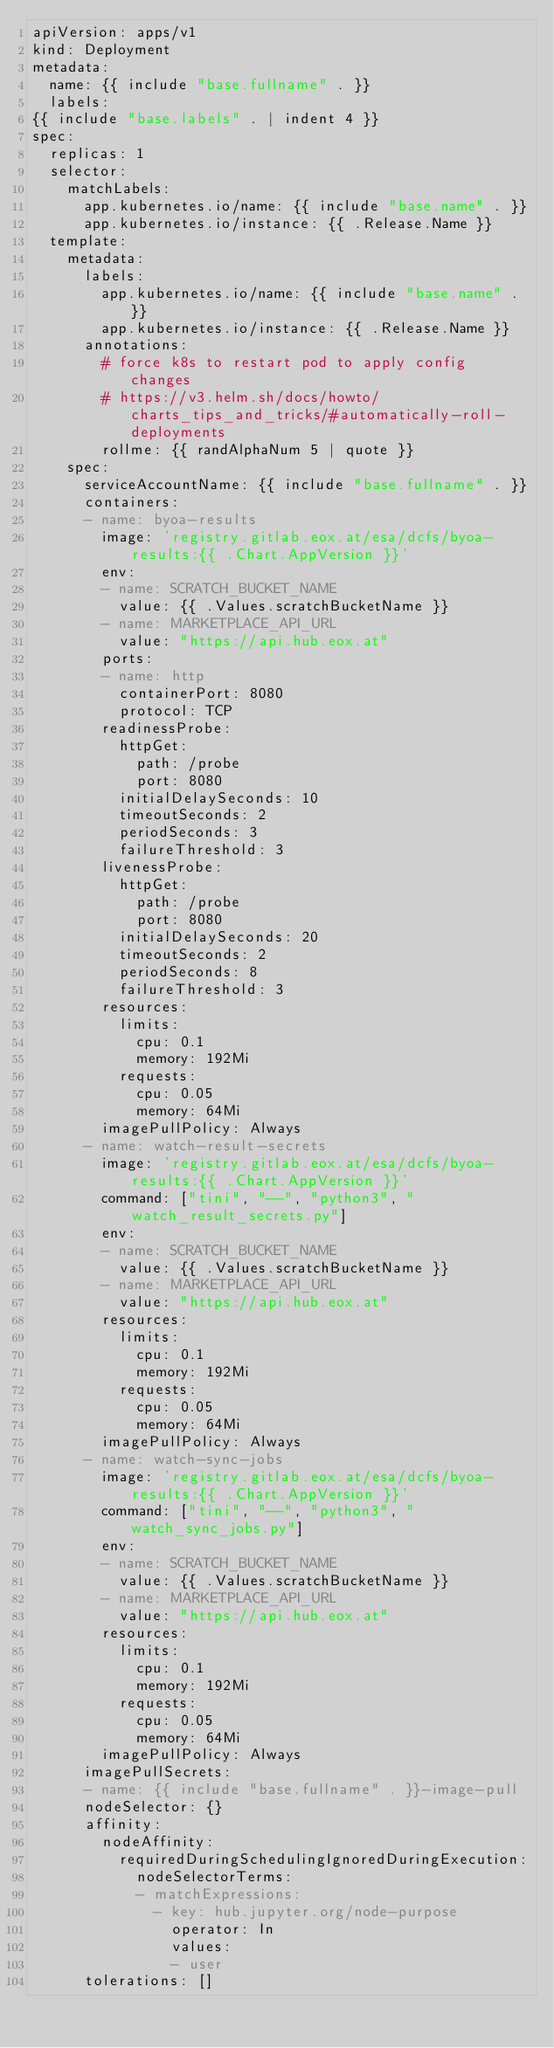Convert code to text. <code><loc_0><loc_0><loc_500><loc_500><_YAML_>apiVersion: apps/v1
kind: Deployment
metadata:
  name: {{ include "base.fullname" . }}
  labels:
{{ include "base.labels" . | indent 4 }}
spec:
  replicas: 1
  selector:
    matchLabels:
      app.kubernetes.io/name: {{ include "base.name" . }}
      app.kubernetes.io/instance: {{ .Release.Name }}
  template:
    metadata:
      labels:
        app.kubernetes.io/name: {{ include "base.name" . }}
        app.kubernetes.io/instance: {{ .Release.Name }}
      annotations:
        # force k8s to restart pod to apply config changes
        # https://v3.helm.sh/docs/howto/charts_tips_and_tricks/#automatically-roll-deployments
        rollme: {{ randAlphaNum 5 | quote }}
    spec:
      serviceAccountName: {{ include "base.fullname" . }}
      containers:
      - name: byoa-results
        image: 'registry.gitlab.eox.at/esa/dcfs/byoa-results:{{ .Chart.AppVersion }}'
        env:
        - name: SCRATCH_BUCKET_NAME
          value: {{ .Values.scratchBucketName }}
        - name: MARKETPLACE_API_URL
          value: "https://api.hub.eox.at"
        ports:
        - name: http
          containerPort: 8080
          protocol: TCP
        readinessProbe:
          httpGet:
            path: /probe
            port: 8080
          initialDelaySeconds: 10
          timeoutSeconds: 2
          periodSeconds: 3
          failureThreshold: 3
        livenessProbe:
          httpGet:
            path: /probe
            port: 8080
          initialDelaySeconds: 20
          timeoutSeconds: 2
          periodSeconds: 8
          failureThreshold: 3
        resources:
          limits:
            cpu: 0.1
            memory: 192Mi
          requests:
            cpu: 0.05
            memory: 64Mi
        imagePullPolicy: Always
      - name: watch-result-secrets
        image: 'registry.gitlab.eox.at/esa/dcfs/byoa-results:{{ .Chart.AppVersion }}'
        command: ["tini", "--", "python3", "watch_result_secrets.py"]
        env:
        - name: SCRATCH_BUCKET_NAME
          value: {{ .Values.scratchBucketName }}
        - name: MARKETPLACE_API_URL
          value: "https://api.hub.eox.at"
        resources:
          limits:
            cpu: 0.1
            memory: 192Mi
          requests:
            cpu: 0.05
            memory: 64Mi
        imagePullPolicy: Always
      - name: watch-sync-jobs
        image: 'registry.gitlab.eox.at/esa/dcfs/byoa-results:{{ .Chart.AppVersion }}'
        command: ["tini", "--", "python3", "watch_sync_jobs.py"]
        env:
        - name: SCRATCH_BUCKET_NAME
          value: {{ .Values.scratchBucketName }}
        - name: MARKETPLACE_API_URL
          value: "https://api.hub.eox.at"
        resources:
          limits:
            cpu: 0.1
            memory: 192Mi
          requests:
            cpu: 0.05
            memory: 64Mi
        imagePullPolicy: Always
      imagePullSecrets:
      - name: {{ include "base.fullname" . }}-image-pull
      nodeSelector: {}
      affinity:
        nodeAffinity:
          requiredDuringSchedulingIgnoredDuringExecution:
            nodeSelectorTerms:
            - matchExpressions:
              - key: hub.jupyter.org/node-purpose
                operator: In
                values:
                - user
      tolerations: []
</code> 